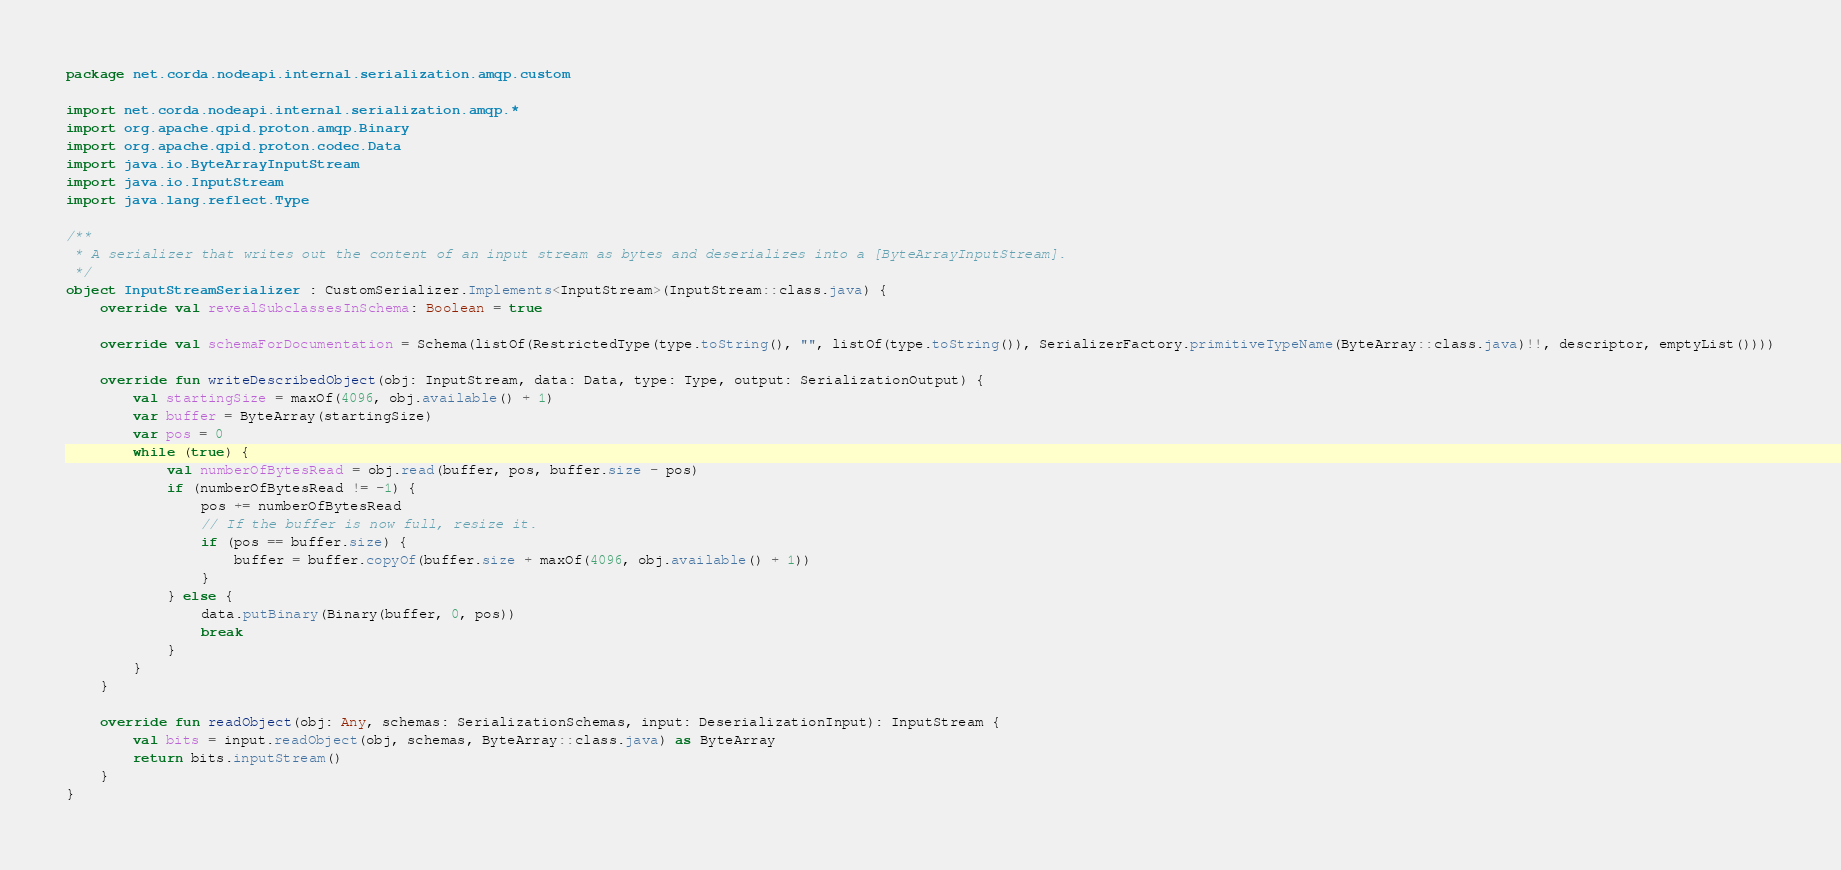Convert code to text. <code><loc_0><loc_0><loc_500><loc_500><_Kotlin_>package net.corda.nodeapi.internal.serialization.amqp.custom

import net.corda.nodeapi.internal.serialization.amqp.*
import org.apache.qpid.proton.amqp.Binary
import org.apache.qpid.proton.codec.Data
import java.io.ByteArrayInputStream
import java.io.InputStream
import java.lang.reflect.Type

/**
 * A serializer that writes out the content of an input stream as bytes and deserializes into a [ByteArrayInputStream].
 */
object InputStreamSerializer : CustomSerializer.Implements<InputStream>(InputStream::class.java) {
    override val revealSubclassesInSchema: Boolean = true

    override val schemaForDocumentation = Schema(listOf(RestrictedType(type.toString(), "", listOf(type.toString()), SerializerFactory.primitiveTypeName(ByteArray::class.java)!!, descriptor, emptyList())))

    override fun writeDescribedObject(obj: InputStream, data: Data, type: Type, output: SerializationOutput) {
        val startingSize = maxOf(4096, obj.available() + 1)
        var buffer = ByteArray(startingSize)
        var pos = 0
        while (true) {
            val numberOfBytesRead = obj.read(buffer, pos, buffer.size - pos)
            if (numberOfBytesRead != -1) {
                pos += numberOfBytesRead
                // If the buffer is now full, resize it.
                if (pos == buffer.size) {
                    buffer = buffer.copyOf(buffer.size + maxOf(4096, obj.available() + 1))
                }
            } else {
                data.putBinary(Binary(buffer, 0, pos))
                break
            }
        }
    }

    override fun readObject(obj: Any, schemas: SerializationSchemas, input: DeserializationInput): InputStream {
        val bits = input.readObject(obj, schemas, ByteArray::class.java) as ByteArray
        return bits.inputStream()
    }
}</code> 